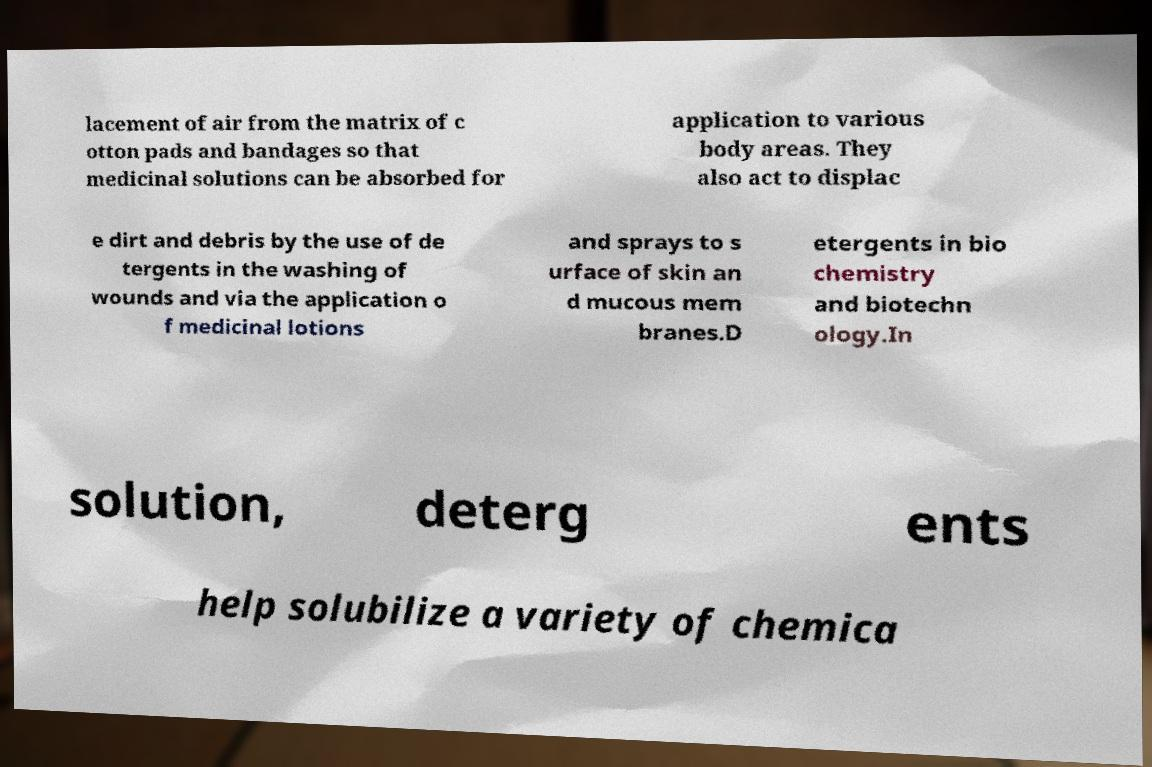Could you assist in decoding the text presented in this image and type it out clearly? lacement of air from the matrix of c otton pads and bandages so that medicinal solutions can be absorbed for application to various body areas. They also act to displac e dirt and debris by the use of de tergents in the washing of wounds and via the application o f medicinal lotions and sprays to s urface of skin an d mucous mem branes.D etergents in bio chemistry and biotechn ology.In solution, deterg ents help solubilize a variety of chemica 